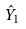Convert formula to latex. <formula><loc_0><loc_0><loc_500><loc_500>\hat { Y } _ { 1 }</formula> 